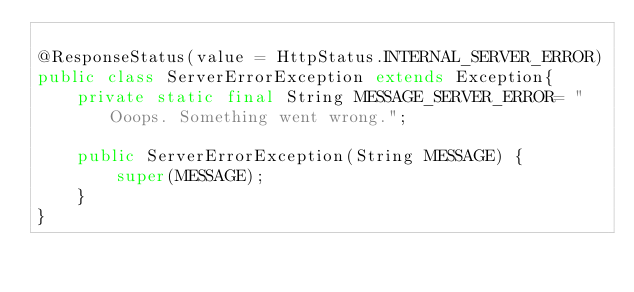<code> <loc_0><loc_0><loc_500><loc_500><_Java_>
@ResponseStatus(value = HttpStatus.INTERNAL_SERVER_ERROR)
public class ServerErrorException extends Exception{
    private static final String MESSAGE_SERVER_ERROR= "Ooops. Something went wrong.";

    public ServerErrorException(String MESSAGE) {
        super(MESSAGE);
    }
}
</code> 